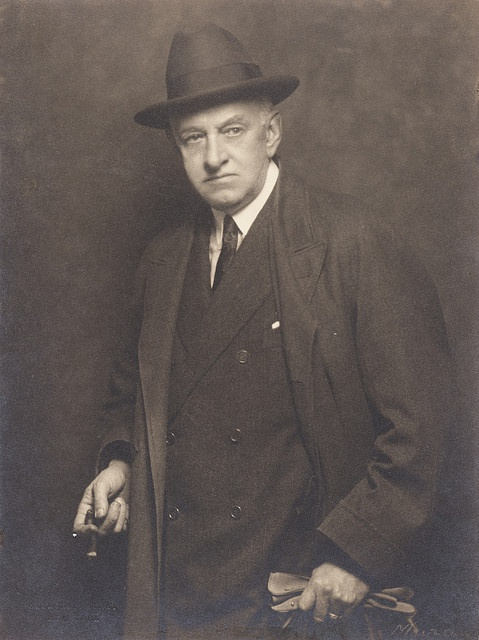Describe the objects in this image and their specific colors. I can see people in gray, tan, and black tones and tie in gray and black tones in this image. 